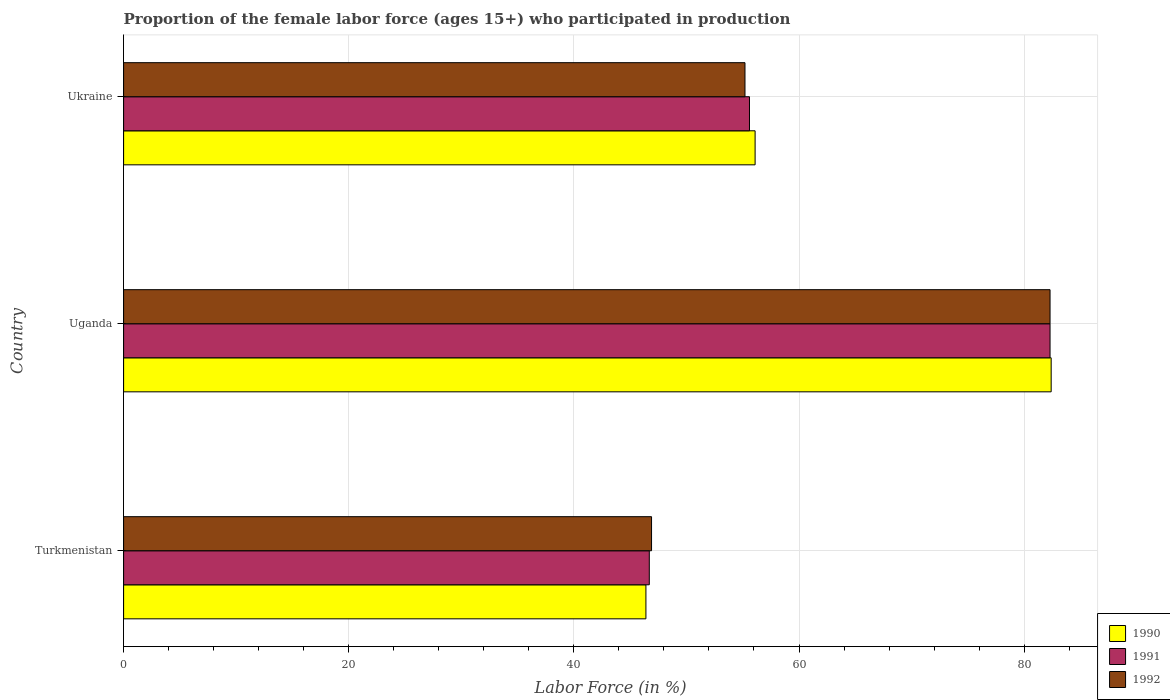How many groups of bars are there?
Give a very brief answer. 3. Are the number of bars per tick equal to the number of legend labels?
Your answer should be very brief. Yes. Are the number of bars on each tick of the Y-axis equal?
Keep it short and to the point. Yes. How many bars are there on the 3rd tick from the bottom?
Your answer should be compact. 3. What is the label of the 2nd group of bars from the top?
Make the answer very short. Uganda. In how many cases, is the number of bars for a given country not equal to the number of legend labels?
Your answer should be very brief. 0. What is the proportion of the female labor force who participated in production in 1992 in Turkmenistan?
Your response must be concise. 46.9. Across all countries, what is the maximum proportion of the female labor force who participated in production in 1990?
Offer a terse response. 82.4. Across all countries, what is the minimum proportion of the female labor force who participated in production in 1991?
Ensure brevity in your answer.  46.7. In which country was the proportion of the female labor force who participated in production in 1991 maximum?
Your answer should be compact. Uganda. In which country was the proportion of the female labor force who participated in production in 1992 minimum?
Provide a short and direct response. Turkmenistan. What is the total proportion of the female labor force who participated in production in 1992 in the graph?
Your answer should be compact. 184.4. What is the difference between the proportion of the female labor force who participated in production in 1990 in Uganda and that in Ukraine?
Provide a short and direct response. 26.3. What is the difference between the proportion of the female labor force who participated in production in 1992 in Uganda and the proportion of the female labor force who participated in production in 1990 in Turkmenistan?
Provide a short and direct response. 35.9. What is the average proportion of the female labor force who participated in production in 1992 per country?
Your response must be concise. 61.47. What is the difference between the proportion of the female labor force who participated in production in 1990 and proportion of the female labor force who participated in production in 1992 in Uganda?
Your response must be concise. 0.1. What is the ratio of the proportion of the female labor force who participated in production in 1992 in Turkmenistan to that in Ukraine?
Offer a very short reply. 0.85. Is the difference between the proportion of the female labor force who participated in production in 1990 in Uganda and Ukraine greater than the difference between the proportion of the female labor force who participated in production in 1992 in Uganda and Ukraine?
Give a very brief answer. No. What is the difference between the highest and the second highest proportion of the female labor force who participated in production in 1992?
Ensure brevity in your answer.  27.1. What is the difference between the highest and the lowest proportion of the female labor force who participated in production in 1990?
Your answer should be compact. 36. Is the sum of the proportion of the female labor force who participated in production in 1991 in Turkmenistan and Uganda greater than the maximum proportion of the female labor force who participated in production in 1990 across all countries?
Provide a short and direct response. Yes. What does the 1st bar from the bottom in Uganda represents?
Your answer should be compact. 1990. Is it the case that in every country, the sum of the proportion of the female labor force who participated in production in 1990 and proportion of the female labor force who participated in production in 1991 is greater than the proportion of the female labor force who participated in production in 1992?
Make the answer very short. Yes. How many bars are there?
Your answer should be very brief. 9. How many countries are there in the graph?
Ensure brevity in your answer.  3. Are the values on the major ticks of X-axis written in scientific E-notation?
Your answer should be compact. No. Does the graph contain grids?
Make the answer very short. Yes. How are the legend labels stacked?
Offer a terse response. Vertical. What is the title of the graph?
Your response must be concise. Proportion of the female labor force (ages 15+) who participated in production. Does "1980" appear as one of the legend labels in the graph?
Ensure brevity in your answer.  No. What is the label or title of the X-axis?
Your answer should be very brief. Labor Force (in %). What is the Labor Force (in %) of 1990 in Turkmenistan?
Offer a terse response. 46.4. What is the Labor Force (in %) of 1991 in Turkmenistan?
Provide a succinct answer. 46.7. What is the Labor Force (in %) of 1992 in Turkmenistan?
Ensure brevity in your answer.  46.9. What is the Labor Force (in %) of 1990 in Uganda?
Provide a succinct answer. 82.4. What is the Labor Force (in %) in 1991 in Uganda?
Make the answer very short. 82.3. What is the Labor Force (in %) of 1992 in Uganda?
Your response must be concise. 82.3. What is the Labor Force (in %) in 1990 in Ukraine?
Ensure brevity in your answer.  56.1. What is the Labor Force (in %) of 1991 in Ukraine?
Your answer should be compact. 55.6. What is the Labor Force (in %) in 1992 in Ukraine?
Give a very brief answer. 55.2. Across all countries, what is the maximum Labor Force (in %) in 1990?
Your answer should be compact. 82.4. Across all countries, what is the maximum Labor Force (in %) of 1991?
Offer a terse response. 82.3. Across all countries, what is the maximum Labor Force (in %) of 1992?
Provide a short and direct response. 82.3. Across all countries, what is the minimum Labor Force (in %) of 1990?
Your response must be concise. 46.4. Across all countries, what is the minimum Labor Force (in %) in 1991?
Make the answer very short. 46.7. Across all countries, what is the minimum Labor Force (in %) of 1992?
Keep it short and to the point. 46.9. What is the total Labor Force (in %) in 1990 in the graph?
Offer a terse response. 184.9. What is the total Labor Force (in %) of 1991 in the graph?
Your answer should be compact. 184.6. What is the total Labor Force (in %) in 1992 in the graph?
Your answer should be very brief. 184.4. What is the difference between the Labor Force (in %) in 1990 in Turkmenistan and that in Uganda?
Keep it short and to the point. -36. What is the difference between the Labor Force (in %) in 1991 in Turkmenistan and that in Uganda?
Give a very brief answer. -35.6. What is the difference between the Labor Force (in %) of 1992 in Turkmenistan and that in Uganda?
Make the answer very short. -35.4. What is the difference between the Labor Force (in %) in 1991 in Turkmenistan and that in Ukraine?
Give a very brief answer. -8.9. What is the difference between the Labor Force (in %) in 1990 in Uganda and that in Ukraine?
Make the answer very short. 26.3. What is the difference between the Labor Force (in %) of 1991 in Uganda and that in Ukraine?
Your answer should be very brief. 26.7. What is the difference between the Labor Force (in %) of 1992 in Uganda and that in Ukraine?
Offer a very short reply. 27.1. What is the difference between the Labor Force (in %) in 1990 in Turkmenistan and the Labor Force (in %) in 1991 in Uganda?
Keep it short and to the point. -35.9. What is the difference between the Labor Force (in %) of 1990 in Turkmenistan and the Labor Force (in %) of 1992 in Uganda?
Give a very brief answer. -35.9. What is the difference between the Labor Force (in %) of 1991 in Turkmenistan and the Labor Force (in %) of 1992 in Uganda?
Offer a very short reply. -35.6. What is the difference between the Labor Force (in %) of 1990 in Turkmenistan and the Labor Force (in %) of 1991 in Ukraine?
Provide a short and direct response. -9.2. What is the difference between the Labor Force (in %) in 1990 in Uganda and the Labor Force (in %) in 1991 in Ukraine?
Give a very brief answer. 26.8. What is the difference between the Labor Force (in %) in 1990 in Uganda and the Labor Force (in %) in 1992 in Ukraine?
Make the answer very short. 27.2. What is the difference between the Labor Force (in %) in 1991 in Uganda and the Labor Force (in %) in 1992 in Ukraine?
Provide a short and direct response. 27.1. What is the average Labor Force (in %) in 1990 per country?
Give a very brief answer. 61.63. What is the average Labor Force (in %) in 1991 per country?
Your answer should be very brief. 61.53. What is the average Labor Force (in %) of 1992 per country?
Make the answer very short. 61.47. What is the difference between the Labor Force (in %) in 1990 and Labor Force (in %) in 1991 in Turkmenistan?
Your answer should be compact. -0.3. What is the difference between the Labor Force (in %) of 1990 and Labor Force (in %) of 1991 in Uganda?
Provide a succinct answer. 0.1. What is the difference between the Labor Force (in %) of 1990 and Labor Force (in %) of 1992 in Uganda?
Offer a very short reply. 0.1. What is the difference between the Labor Force (in %) in 1991 and Labor Force (in %) in 1992 in Uganda?
Give a very brief answer. 0. What is the difference between the Labor Force (in %) in 1990 and Labor Force (in %) in 1991 in Ukraine?
Make the answer very short. 0.5. What is the ratio of the Labor Force (in %) of 1990 in Turkmenistan to that in Uganda?
Your answer should be very brief. 0.56. What is the ratio of the Labor Force (in %) of 1991 in Turkmenistan to that in Uganda?
Your response must be concise. 0.57. What is the ratio of the Labor Force (in %) in 1992 in Turkmenistan to that in Uganda?
Ensure brevity in your answer.  0.57. What is the ratio of the Labor Force (in %) in 1990 in Turkmenistan to that in Ukraine?
Provide a short and direct response. 0.83. What is the ratio of the Labor Force (in %) in 1991 in Turkmenistan to that in Ukraine?
Ensure brevity in your answer.  0.84. What is the ratio of the Labor Force (in %) of 1992 in Turkmenistan to that in Ukraine?
Offer a terse response. 0.85. What is the ratio of the Labor Force (in %) of 1990 in Uganda to that in Ukraine?
Ensure brevity in your answer.  1.47. What is the ratio of the Labor Force (in %) of 1991 in Uganda to that in Ukraine?
Offer a very short reply. 1.48. What is the ratio of the Labor Force (in %) in 1992 in Uganda to that in Ukraine?
Your answer should be compact. 1.49. What is the difference between the highest and the second highest Labor Force (in %) in 1990?
Your answer should be very brief. 26.3. What is the difference between the highest and the second highest Labor Force (in %) in 1991?
Give a very brief answer. 26.7. What is the difference between the highest and the second highest Labor Force (in %) in 1992?
Your answer should be very brief. 27.1. What is the difference between the highest and the lowest Labor Force (in %) of 1991?
Provide a short and direct response. 35.6. What is the difference between the highest and the lowest Labor Force (in %) of 1992?
Your answer should be compact. 35.4. 